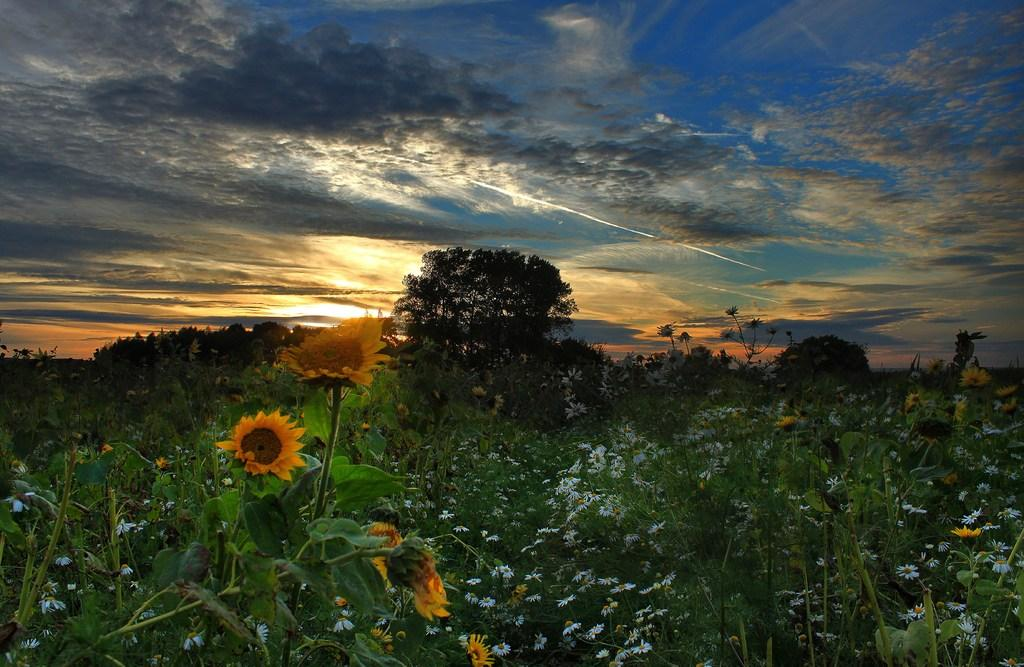What type of vegetation can be seen in the image? There are flowers, plants, and trees in the image. What part of the natural environment is visible in the image? The sky is visible in the image. How many kittens are sitting on the neck of the station in the image? There are no kittens or stations present in the image. 